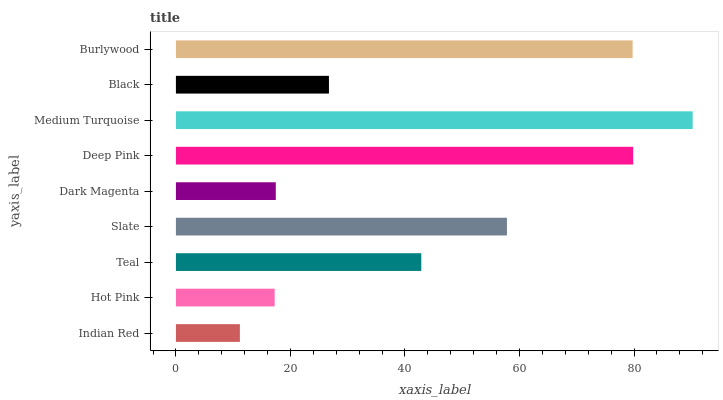Is Indian Red the minimum?
Answer yes or no. Yes. Is Medium Turquoise the maximum?
Answer yes or no. Yes. Is Hot Pink the minimum?
Answer yes or no. No. Is Hot Pink the maximum?
Answer yes or no. No. Is Hot Pink greater than Indian Red?
Answer yes or no. Yes. Is Indian Red less than Hot Pink?
Answer yes or no. Yes. Is Indian Red greater than Hot Pink?
Answer yes or no. No. Is Hot Pink less than Indian Red?
Answer yes or no. No. Is Teal the high median?
Answer yes or no. Yes. Is Teal the low median?
Answer yes or no. Yes. Is Medium Turquoise the high median?
Answer yes or no. No. Is Dark Magenta the low median?
Answer yes or no. No. 